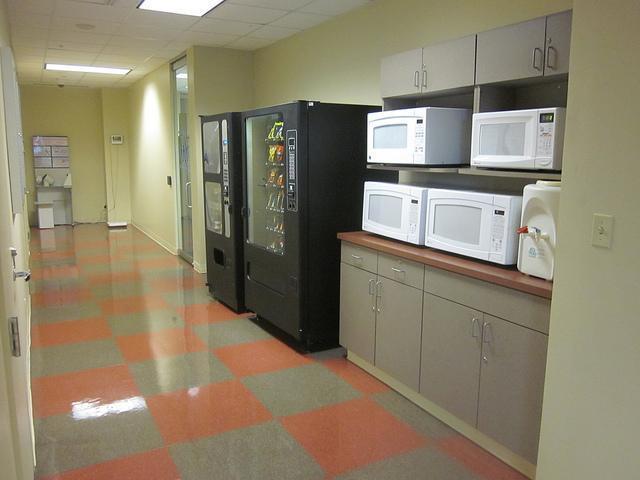How many microwaves are there?
Give a very brief answer. 4. How many vending machines are in this room?
Give a very brief answer. 2. How many cabinets are there?
Give a very brief answer. 8. How many refrigerators are in the picture?
Give a very brief answer. 2. How many people wearning top?
Give a very brief answer. 0. 